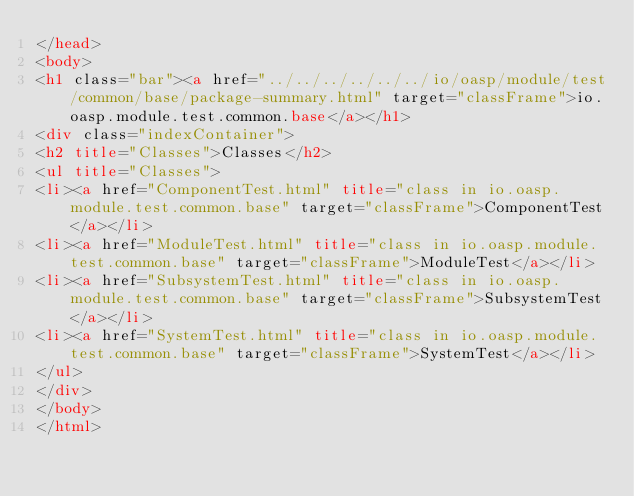Convert code to text. <code><loc_0><loc_0><loc_500><loc_500><_HTML_></head>
<body>
<h1 class="bar"><a href="../../../../../../io/oasp/module/test/common/base/package-summary.html" target="classFrame">io.oasp.module.test.common.base</a></h1>
<div class="indexContainer">
<h2 title="Classes">Classes</h2>
<ul title="Classes">
<li><a href="ComponentTest.html" title="class in io.oasp.module.test.common.base" target="classFrame">ComponentTest</a></li>
<li><a href="ModuleTest.html" title="class in io.oasp.module.test.common.base" target="classFrame">ModuleTest</a></li>
<li><a href="SubsystemTest.html" title="class in io.oasp.module.test.common.base" target="classFrame">SubsystemTest</a></li>
<li><a href="SystemTest.html" title="class in io.oasp.module.test.common.base" target="classFrame">SystemTest</a></li>
</ul>
</div>
</body>
</html>
</code> 